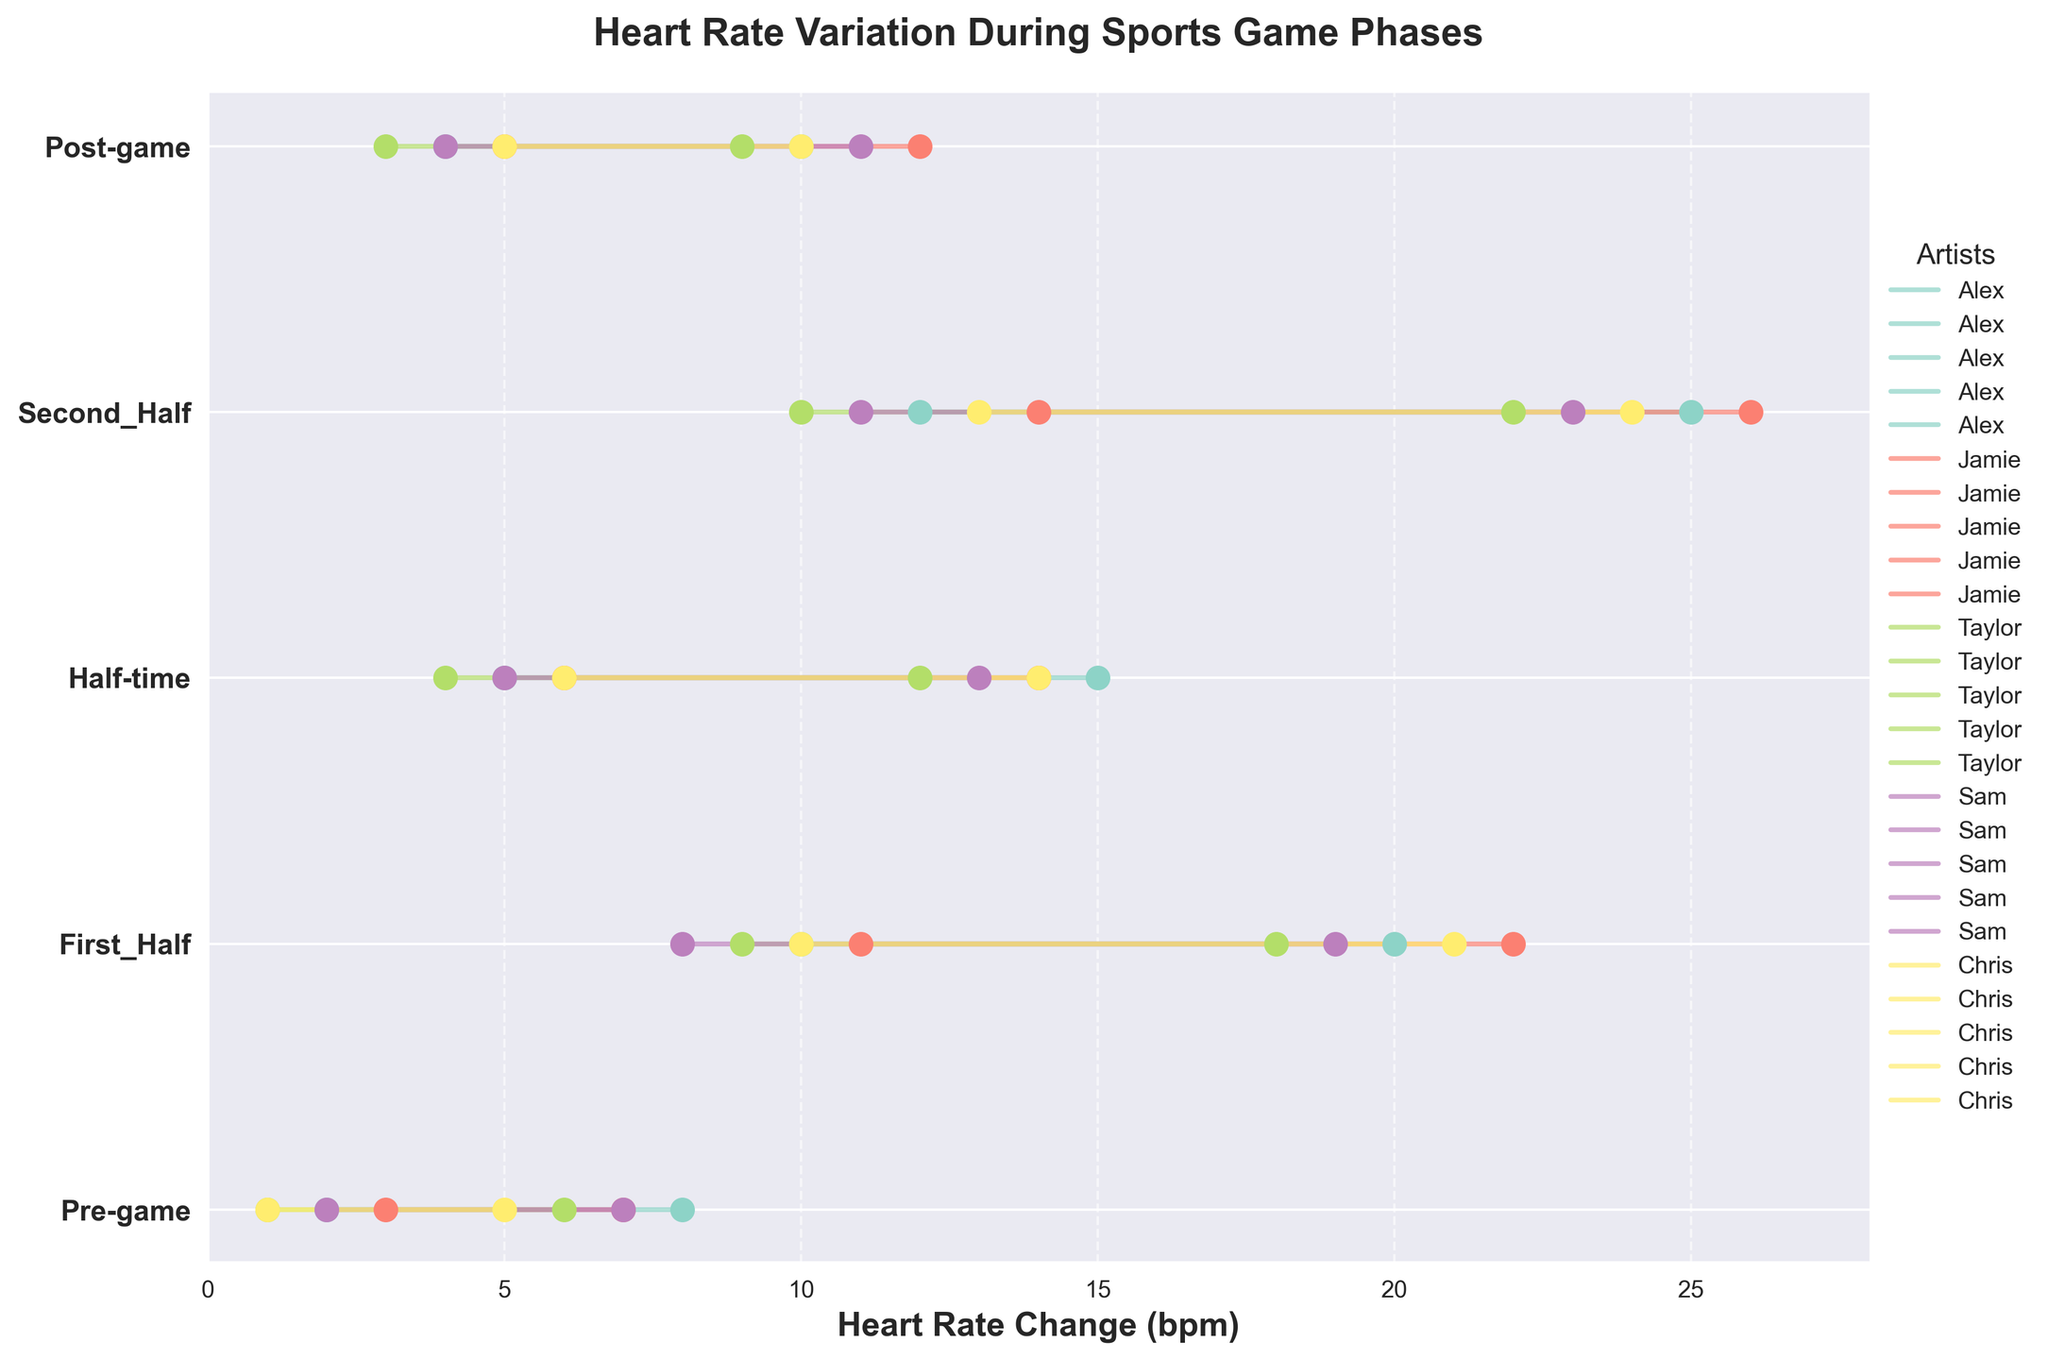What is the range of heart rate changes for Alex during the Second Half? The range of heart rate changes is determined by subtracting the minimum heart rate change from the maximum heart rate change. For Alex during the Second Half, the minimum heart rate change is 12 and the maximum is 25. So, the range is 25 - 12.
Answer: 13 Between Jamie and Chris, who had a higher maximum heart rate change during the First Half? To determine who had a higher maximum heart rate change, compare the maximum values for Jamie and Chris during the First Half. Jamie's maximum is 22 and Chris's maximum is 21.
Answer: Jamie By how much did Sam's maximum heart rate change differ between the Pre-game and Post-game phases? To find the difference, subtract the maximum heart rate change in the Post-game from the maximum heart rate change in the Pre-game. For Sam, the Pre-game maximum is 7 and the Post-game maximum is 11. So, 11 - 7.
Answer: 4 Which phase had the widest range of heart rate changes for Taylor? To determine the phase with the widest range, calculate the range of heart rate changes for each phase Taylor experienced and compare them. The ranges are as follows: Pre-game (6 - 1 = 5), First Half (18 - 9 = 9), Half-time (12 - 4 = 8), Second Half (22 - 10 = 12), Post-game (9 - 3 = 6). The widest range is 12 in the Second Half.
Answer: Second Half What is the average maximum heart rate change for all artists during the Half-time phase? To calculate the average, sum the maximum heart rate changes during the Half-time phase for all artists and divide by the number of artists. The maximum values are 15, 14, 12, 13, and 14. The sum is 68, and there are 5 artists, so 68/5.
Answer: 13.6 